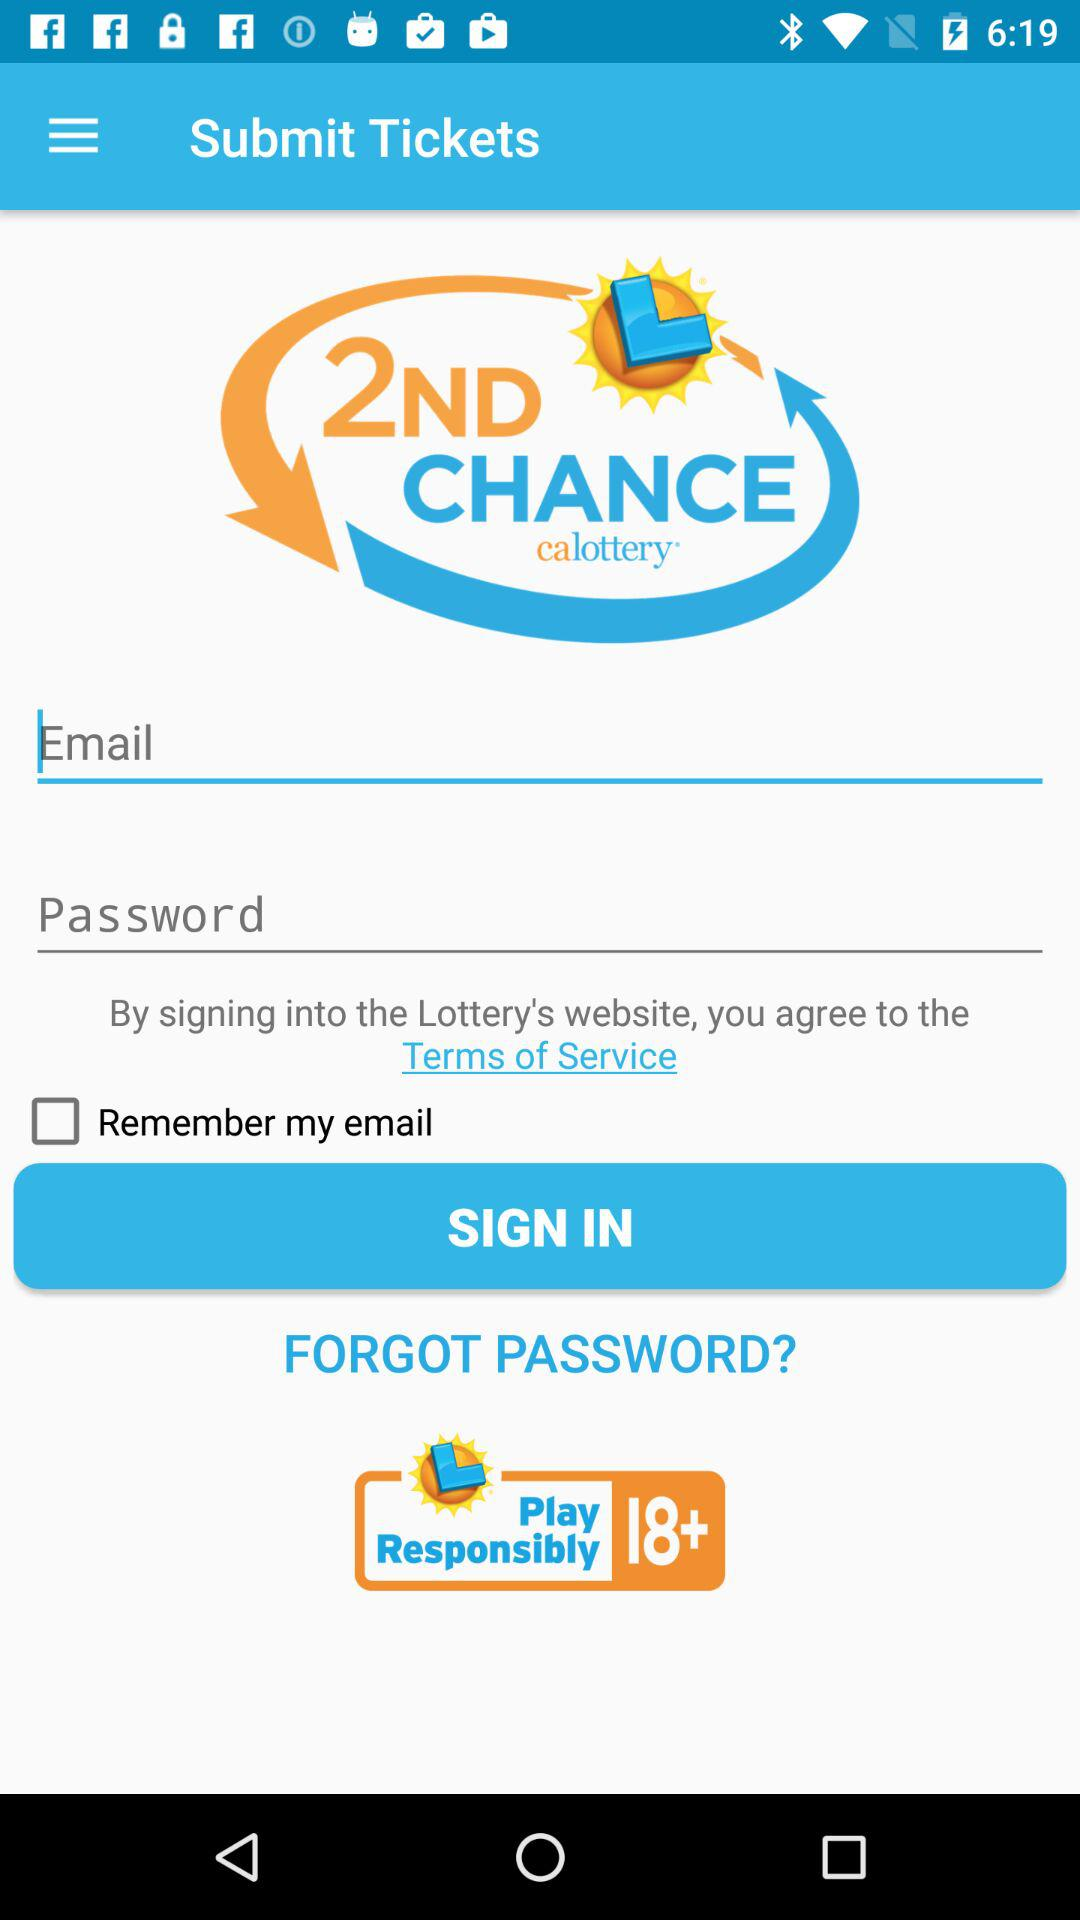What is the status of "Remember my email"? The status is "off". 